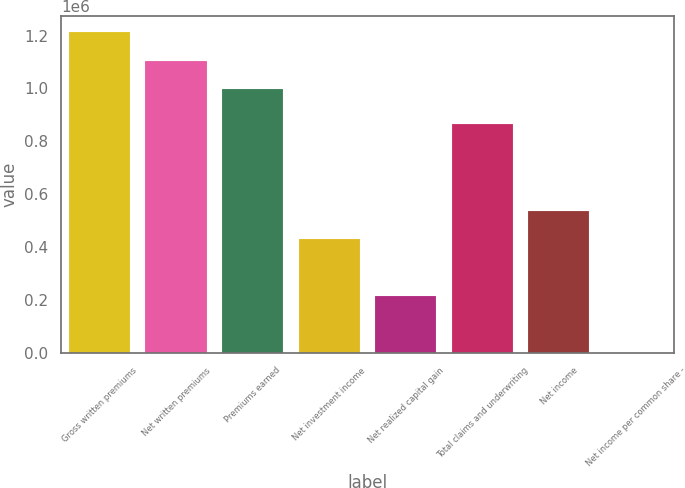Convert chart. <chart><loc_0><loc_0><loc_500><loc_500><bar_chart><fcel>Gross written premiums<fcel>Net written premiums<fcel>Premiums earned<fcel>Net investment income<fcel>Net realized capital gain<fcel>Total claims and underwriting<fcel>Net income<fcel>Net income per common share -<nl><fcel>1.21199e+06<fcel>1.10452e+06<fcel>997055<fcel>429872<fcel>214938<fcel>863691<fcel>537338<fcel>3.9<nl></chart> 